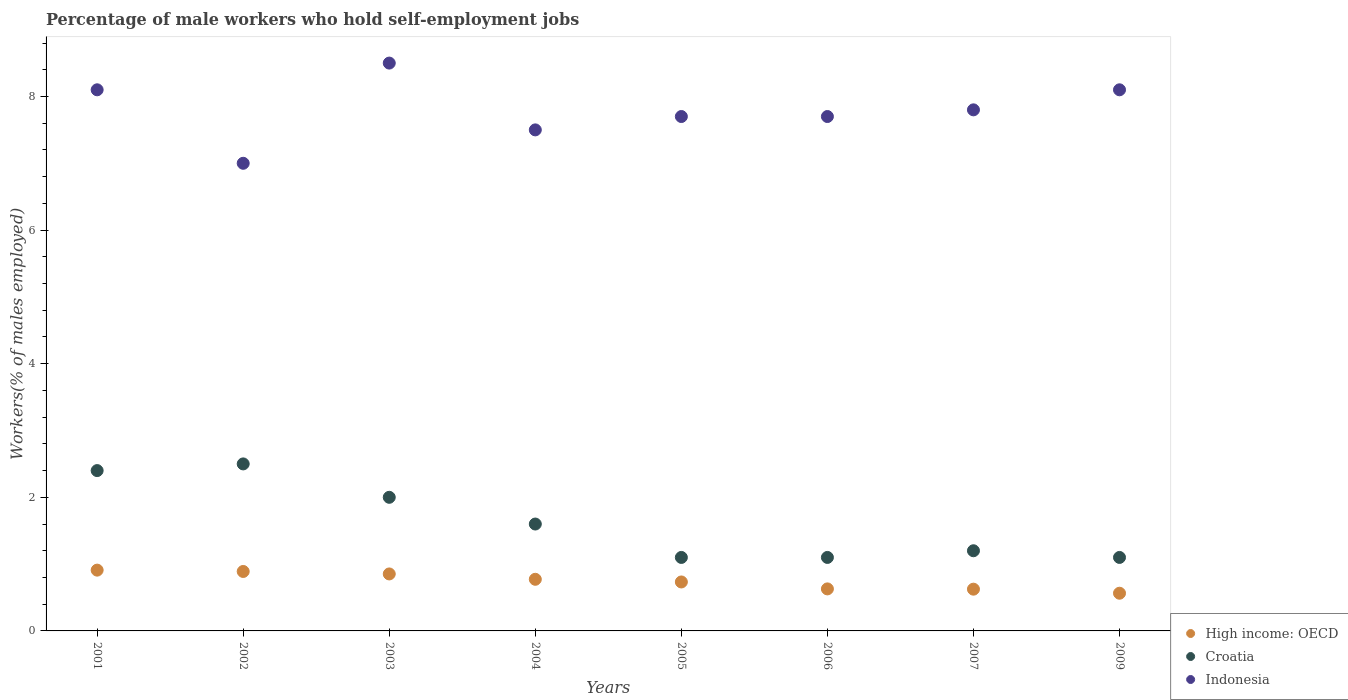How many different coloured dotlines are there?
Make the answer very short. 3. What is the percentage of self-employed male workers in Croatia in 2009?
Give a very brief answer. 1.1. Across all years, what is the minimum percentage of self-employed male workers in High income: OECD?
Make the answer very short. 0.56. What is the total percentage of self-employed male workers in Croatia in the graph?
Offer a terse response. 13. What is the difference between the percentage of self-employed male workers in Indonesia in 2006 and that in 2007?
Give a very brief answer. -0.1. What is the difference between the percentage of self-employed male workers in High income: OECD in 2004 and the percentage of self-employed male workers in Croatia in 2007?
Provide a short and direct response. -0.43. What is the average percentage of self-employed male workers in High income: OECD per year?
Your response must be concise. 0.75. In the year 2006, what is the difference between the percentage of self-employed male workers in Croatia and percentage of self-employed male workers in High income: OECD?
Make the answer very short. 0.47. What is the ratio of the percentage of self-employed male workers in Croatia in 2001 to that in 2009?
Your response must be concise. 2.18. Is the difference between the percentage of self-employed male workers in Croatia in 2005 and 2007 greater than the difference between the percentage of self-employed male workers in High income: OECD in 2005 and 2007?
Ensure brevity in your answer.  No. What is the difference between the highest and the second highest percentage of self-employed male workers in Indonesia?
Provide a short and direct response. 0.4. What is the difference between the highest and the lowest percentage of self-employed male workers in High income: OECD?
Provide a succinct answer. 0.35. In how many years, is the percentage of self-employed male workers in Indonesia greater than the average percentage of self-employed male workers in Indonesia taken over all years?
Keep it short and to the point. 4. Is the sum of the percentage of self-employed male workers in Indonesia in 2004 and 2007 greater than the maximum percentage of self-employed male workers in High income: OECD across all years?
Make the answer very short. Yes. Is it the case that in every year, the sum of the percentage of self-employed male workers in Indonesia and percentage of self-employed male workers in Croatia  is greater than the percentage of self-employed male workers in High income: OECD?
Your answer should be very brief. Yes. Does the percentage of self-employed male workers in Indonesia monotonically increase over the years?
Ensure brevity in your answer.  No. Is the percentage of self-employed male workers in Indonesia strictly greater than the percentage of self-employed male workers in High income: OECD over the years?
Keep it short and to the point. Yes. Is the percentage of self-employed male workers in High income: OECD strictly less than the percentage of self-employed male workers in Croatia over the years?
Provide a short and direct response. Yes. How many years are there in the graph?
Your answer should be very brief. 8. Are the values on the major ticks of Y-axis written in scientific E-notation?
Your response must be concise. No. Does the graph contain any zero values?
Offer a very short reply. No. Does the graph contain grids?
Ensure brevity in your answer.  No. What is the title of the graph?
Provide a succinct answer. Percentage of male workers who hold self-employment jobs. What is the label or title of the X-axis?
Provide a short and direct response. Years. What is the label or title of the Y-axis?
Offer a very short reply. Workers(% of males employed). What is the Workers(% of males employed) in High income: OECD in 2001?
Your answer should be very brief. 0.91. What is the Workers(% of males employed) in Croatia in 2001?
Your answer should be very brief. 2.4. What is the Workers(% of males employed) of Indonesia in 2001?
Provide a short and direct response. 8.1. What is the Workers(% of males employed) of High income: OECD in 2002?
Give a very brief answer. 0.89. What is the Workers(% of males employed) in High income: OECD in 2003?
Provide a short and direct response. 0.85. What is the Workers(% of males employed) in High income: OECD in 2004?
Your answer should be compact. 0.77. What is the Workers(% of males employed) in Croatia in 2004?
Provide a succinct answer. 1.6. What is the Workers(% of males employed) of High income: OECD in 2005?
Provide a succinct answer. 0.73. What is the Workers(% of males employed) of Croatia in 2005?
Give a very brief answer. 1.1. What is the Workers(% of males employed) of Indonesia in 2005?
Your answer should be very brief. 7.7. What is the Workers(% of males employed) of High income: OECD in 2006?
Your answer should be compact. 0.63. What is the Workers(% of males employed) of Croatia in 2006?
Give a very brief answer. 1.1. What is the Workers(% of males employed) in Indonesia in 2006?
Your answer should be compact. 7.7. What is the Workers(% of males employed) in High income: OECD in 2007?
Provide a succinct answer. 0.62. What is the Workers(% of males employed) of Croatia in 2007?
Offer a very short reply. 1.2. What is the Workers(% of males employed) in Indonesia in 2007?
Your response must be concise. 7.8. What is the Workers(% of males employed) of High income: OECD in 2009?
Your response must be concise. 0.56. What is the Workers(% of males employed) of Croatia in 2009?
Provide a short and direct response. 1.1. What is the Workers(% of males employed) in Indonesia in 2009?
Your answer should be compact. 8.1. Across all years, what is the maximum Workers(% of males employed) of High income: OECD?
Offer a very short reply. 0.91. Across all years, what is the maximum Workers(% of males employed) of Croatia?
Your response must be concise. 2.5. Across all years, what is the minimum Workers(% of males employed) of High income: OECD?
Ensure brevity in your answer.  0.56. Across all years, what is the minimum Workers(% of males employed) of Croatia?
Ensure brevity in your answer.  1.1. Across all years, what is the minimum Workers(% of males employed) in Indonesia?
Offer a terse response. 7. What is the total Workers(% of males employed) in High income: OECD in the graph?
Ensure brevity in your answer.  5.98. What is the total Workers(% of males employed) of Indonesia in the graph?
Keep it short and to the point. 62.4. What is the difference between the Workers(% of males employed) in High income: OECD in 2001 and that in 2003?
Your response must be concise. 0.06. What is the difference between the Workers(% of males employed) in Indonesia in 2001 and that in 2003?
Offer a terse response. -0.4. What is the difference between the Workers(% of males employed) in High income: OECD in 2001 and that in 2004?
Make the answer very short. 0.14. What is the difference between the Workers(% of males employed) in Indonesia in 2001 and that in 2004?
Your answer should be very brief. 0.6. What is the difference between the Workers(% of males employed) of High income: OECD in 2001 and that in 2005?
Your answer should be compact. 0.18. What is the difference between the Workers(% of males employed) of Croatia in 2001 and that in 2005?
Offer a terse response. 1.3. What is the difference between the Workers(% of males employed) of Indonesia in 2001 and that in 2005?
Offer a very short reply. 0.4. What is the difference between the Workers(% of males employed) of High income: OECD in 2001 and that in 2006?
Provide a succinct answer. 0.28. What is the difference between the Workers(% of males employed) of High income: OECD in 2001 and that in 2007?
Your answer should be very brief. 0.28. What is the difference between the Workers(% of males employed) in Croatia in 2001 and that in 2007?
Your answer should be compact. 1.2. What is the difference between the Workers(% of males employed) of Indonesia in 2001 and that in 2007?
Your answer should be compact. 0.3. What is the difference between the Workers(% of males employed) of High income: OECD in 2001 and that in 2009?
Ensure brevity in your answer.  0.35. What is the difference between the Workers(% of males employed) in Croatia in 2001 and that in 2009?
Ensure brevity in your answer.  1.3. What is the difference between the Workers(% of males employed) of Indonesia in 2001 and that in 2009?
Offer a terse response. 0. What is the difference between the Workers(% of males employed) in High income: OECD in 2002 and that in 2003?
Offer a terse response. 0.04. What is the difference between the Workers(% of males employed) of Croatia in 2002 and that in 2003?
Make the answer very short. 0.5. What is the difference between the Workers(% of males employed) in High income: OECD in 2002 and that in 2004?
Provide a succinct answer. 0.12. What is the difference between the Workers(% of males employed) in High income: OECD in 2002 and that in 2005?
Offer a very short reply. 0.16. What is the difference between the Workers(% of males employed) of High income: OECD in 2002 and that in 2006?
Your answer should be compact. 0.26. What is the difference between the Workers(% of males employed) of Croatia in 2002 and that in 2006?
Your response must be concise. 1.4. What is the difference between the Workers(% of males employed) of Indonesia in 2002 and that in 2006?
Your response must be concise. -0.7. What is the difference between the Workers(% of males employed) of High income: OECD in 2002 and that in 2007?
Give a very brief answer. 0.27. What is the difference between the Workers(% of males employed) in Croatia in 2002 and that in 2007?
Provide a succinct answer. 1.3. What is the difference between the Workers(% of males employed) in High income: OECD in 2002 and that in 2009?
Keep it short and to the point. 0.33. What is the difference between the Workers(% of males employed) of Croatia in 2002 and that in 2009?
Your answer should be very brief. 1.4. What is the difference between the Workers(% of males employed) in High income: OECD in 2003 and that in 2004?
Make the answer very short. 0.08. What is the difference between the Workers(% of males employed) in Croatia in 2003 and that in 2004?
Ensure brevity in your answer.  0.4. What is the difference between the Workers(% of males employed) of High income: OECD in 2003 and that in 2005?
Your answer should be very brief. 0.12. What is the difference between the Workers(% of males employed) in Indonesia in 2003 and that in 2005?
Your response must be concise. 0.8. What is the difference between the Workers(% of males employed) of High income: OECD in 2003 and that in 2006?
Keep it short and to the point. 0.22. What is the difference between the Workers(% of males employed) of Croatia in 2003 and that in 2006?
Your answer should be compact. 0.9. What is the difference between the Workers(% of males employed) of Indonesia in 2003 and that in 2006?
Provide a short and direct response. 0.8. What is the difference between the Workers(% of males employed) of High income: OECD in 2003 and that in 2007?
Ensure brevity in your answer.  0.23. What is the difference between the Workers(% of males employed) in High income: OECD in 2003 and that in 2009?
Ensure brevity in your answer.  0.29. What is the difference between the Workers(% of males employed) in High income: OECD in 2004 and that in 2005?
Give a very brief answer. 0.04. What is the difference between the Workers(% of males employed) in Croatia in 2004 and that in 2005?
Make the answer very short. 0.5. What is the difference between the Workers(% of males employed) in High income: OECD in 2004 and that in 2006?
Offer a terse response. 0.14. What is the difference between the Workers(% of males employed) of High income: OECD in 2004 and that in 2007?
Keep it short and to the point. 0.15. What is the difference between the Workers(% of males employed) in High income: OECD in 2004 and that in 2009?
Give a very brief answer. 0.21. What is the difference between the Workers(% of males employed) of High income: OECD in 2005 and that in 2006?
Your response must be concise. 0.1. What is the difference between the Workers(% of males employed) in High income: OECD in 2005 and that in 2007?
Your answer should be very brief. 0.11. What is the difference between the Workers(% of males employed) of Indonesia in 2005 and that in 2007?
Give a very brief answer. -0.1. What is the difference between the Workers(% of males employed) of High income: OECD in 2005 and that in 2009?
Keep it short and to the point. 0.17. What is the difference between the Workers(% of males employed) of Croatia in 2005 and that in 2009?
Provide a succinct answer. 0. What is the difference between the Workers(% of males employed) of Indonesia in 2005 and that in 2009?
Keep it short and to the point. -0.4. What is the difference between the Workers(% of males employed) of High income: OECD in 2006 and that in 2007?
Your response must be concise. 0. What is the difference between the Workers(% of males employed) in Croatia in 2006 and that in 2007?
Keep it short and to the point. -0.1. What is the difference between the Workers(% of males employed) in Indonesia in 2006 and that in 2007?
Offer a terse response. -0.1. What is the difference between the Workers(% of males employed) of High income: OECD in 2006 and that in 2009?
Provide a short and direct response. 0.06. What is the difference between the Workers(% of males employed) of Croatia in 2006 and that in 2009?
Keep it short and to the point. 0. What is the difference between the Workers(% of males employed) of Indonesia in 2006 and that in 2009?
Your answer should be very brief. -0.4. What is the difference between the Workers(% of males employed) in High income: OECD in 2007 and that in 2009?
Provide a succinct answer. 0.06. What is the difference between the Workers(% of males employed) in High income: OECD in 2001 and the Workers(% of males employed) in Croatia in 2002?
Your response must be concise. -1.59. What is the difference between the Workers(% of males employed) of High income: OECD in 2001 and the Workers(% of males employed) of Indonesia in 2002?
Offer a terse response. -6.09. What is the difference between the Workers(% of males employed) in Croatia in 2001 and the Workers(% of males employed) in Indonesia in 2002?
Your answer should be compact. -4.6. What is the difference between the Workers(% of males employed) in High income: OECD in 2001 and the Workers(% of males employed) in Croatia in 2003?
Offer a very short reply. -1.09. What is the difference between the Workers(% of males employed) in High income: OECD in 2001 and the Workers(% of males employed) in Indonesia in 2003?
Your response must be concise. -7.59. What is the difference between the Workers(% of males employed) of Croatia in 2001 and the Workers(% of males employed) of Indonesia in 2003?
Make the answer very short. -6.1. What is the difference between the Workers(% of males employed) in High income: OECD in 2001 and the Workers(% of males employed) in Croatia in 2004?
Keep it short and to the point. -0.69. What is the difference between the Workers(% of males employed) of High income: OECD in 2001 and the Workers(% of males employed) of Indonesia in 2004?
Keep it short and to the point. -6.59. What is the difference between the Workers(% of males employed) in High income: OECD in 2001 and the Workers(% of males employed) in Croatia in 2005?
Give a very brief answer. -0.19. What is the difference between the Workers(% of males employed) in High income: OECD in 2001 and the Workers(% of males employed) in Indonesia in 2005?
Provide a succinct answer. -6.79. What is the difference between the Workers(% of males employed) in Croatia in 2001 and the Workers(% of males employed) in Indonesia in 2005?
Offer a terse response. -5.3. What is the difference between the Workers(% of males employed) of High income: OECD in 2001 and the Workers(% of males employed) of Croatia in 2006?
Offer a very short reply. -0.19. What is the difference between the Workers(% of males employed) in High income: OECD in 2001 and the Workers(% of males employed) in Indonesia in 2006?
Your response must be concise. -6.79. What is the difference between the Workers(% of males employed) in High income: OECD in 2001 and the Workers(% of males employed) in Croatia in 2007?
Your answer should be very brief. -0.29. What is the difference between the Workers(% of males employed) in High income: OECD in 2001 and the Workers(% of males employed) in Indonesia in 2007?
Give a very brief answer. -6.89. What is the difference between the Workers(% of males employed) in Croatia in 2001 and the Workers(% of males employed) in Indonesia in 2007?
Keep it short and to the point. -5.4. What is the difference between the Workers(% of males employed) of High income: OECD in 2001 and the Workers(% of males employed) of Croatia in 2009?
Keep it short and to the point. -0.19. What is the difference between the Workers(% of males employed) of High income: OECD in 2001 and the Workers(% of males employed) of Indonesia in 2009?
Offer a terse response. -7.19. What is the difference between the Workers(% of males employed) in Croatia in 2001 and the Workers(% of males employed) in Indonesia in 2009?
Provide a succinct answer. -5.7. What is the difference between the Workers(% of males employed) in High income: OECD in 2002 and the Workers(% of males employed) in Croatia in 2003?
Your answer should be compact. -1.11. What is the difference between the Workers(% of males employed) of High income: OECD in 2002 and the Workers(% of males employed) of Indonesia in 2003?
Provide a short and direct response. -7.61. What is the difference between the Workers(% of males employed) in High income: OECD in 2002 and the Workers(% of males employed) in Croatia in 2004?
Give a very brief answer. -0.71. What is the difference between the Workers(% of males employed) in High income: OECD in 2002 and the Workers(% of males employed) in Indonesia in 2004?
Offer a very short reply. -6.61. What is the difference between the Workers(% of males employed) of Croatia in 2002 and the Workers(% of males employed) of Indonesia in 2004?
Your response must be concise. -5. What is the difference between the Workers(% of males employed) in High income: OECD in 2002 and the Workers(% of males employed) in Croatia in 2005?
Give a very brief answer. -0.21. What is the difference between the Workers(% of males employed) in High income: OECD in 2002 and the Workers(% of males employed) in Indonesia in 2005?
Your answer should be very brief. -6.81. What is the difference between the Workers(% of males employed) of Croatia in 2002 and the Workers(% of males employed) of Indonesia in 2005?
Offer a terse response. -5.2. What is the difference between the Workers(% of males employed) of High income: OECD in 2002 and the Workers(% of males employed) of Croatia in 2006?
Offer a very short reply. -0.21. What is the difference between the Workers(% of males employed) of High income: OECD in 2002 and the Workers(% of males employed) of Indonesia in 2006?
Offer a terse response. -6.81. What is the difference between the Workers(% of males employed) in High income: OECD in 2002 and the Workers(% of males employed) in Croatia in 2007?
Offer a very short reply. -0.31. What is the difference between the Workers(% of males employed) of High income: OECD in 2002 and the Workers(% of males employed) of Indonesia in 2007?
Provide a succinct answer. -6.91. What is the difference between the Workers(% of males employed) in High income: OECD in 2002 and the Workers(% of males employed) in Croatia in 2009?
Offer a very short reply. -0.21. What is the difference between the Workers(% of males employed) in High income: OECD in 2002 and the Workers(% of males employed) in Indonesia in 2009?
Provide a succinct answer. -7.21. What is the difference between the Workers(% of males employed) of Croatia in 2002 and the Workers(% of males employed) of Indonesia in 2009?
Offer a very short reply. -5.6. What is the difference between the Workers(% of males employed) of High income: OECD in 2003 and the Workers(% of males employed) of Croatia in 2004?
Your response must be concise. -0.75. What is the difference between the Workers(% of males employed) of High income: OECD in 2003 and the Workers(% of males employed) of Indonesia in 2004?
Offer a very short reply. -6.65. What is the difference between the Workers(% of males employed) in Croatia in 2003 and the Workers(% of males employed) in Indonesia in 2004?
Keep it short and to the point. -5.5. What is the difference between the Workers(% of males employed) of High income: OECD in 2003 and the Workers(% of males employed) of Croatia in 2005?
Provide a succinct answer. -0.25. What is the difference between the Workers(% of males employed) of High income: OECD in 2003 and the Workers(% of males employed) of Indonesia in 2005?
Provide a short and direct response. -6.85. What is the difference between the Workers(% of males employed) in High income: OECD in 2003 and the Workers(% of males employed) in Croatia in 2006?
Offer a very short reply. -0.25. What is the difference between the Workers(% of males employed) of High income: OECD in 2003 and the Workers(% of males employed) of Indonesia in 2006?
Ensure brevity in your answer.  -6.85. What is the difference between the Workers(% of males employed) in High income: OECD in 2003 and the Workers(% of males employed) in Croatia in 2007?
Give a very brief answer. -0.35. What is the difference between the Workers(% of males employed) in High income: OECD in 2003 and the Workers(% of males employed) in Indonesia in 2007?
Offer a terse response. -6.95. What is the difference between the Workers(% of males employed) of Croatia in 2003 and the Workers(% of males employed) of Indonesia in 2007?
Give a very brief answer. -5.8. What is the difference between the Workers(% of males employed) in High income: OECD in 2003 and the Workers(% of males employed) in Croatia in 2009?
Your answer should be very brief. -0.25. What is the difference between the Workers(% of males employed) of High income: OECD in 2003 and the Workers(% of males employed) of Indonesia in 2009?
Ensure brevity in your answer.  -7.25. What is the difference between the Workers(% of males employed) in High income: OECD in 2004 and the Workers(% of males employed) in Croatia in 2005?
Your response must be concise. -0.33. What is the difference between the Workers(% of males employed) in High income: OECD in 2004 and the Workers(% of males employed) in Indonesia in 2005?
Your answer should be very brief. -6.93. What is the difference between the Workers(% of males employed) of Croatia in 2004 and the Workers(% of males employed) of Indonesia in 2005?
Offer a terse response. -6.1. What is the difference between the Workers(% of males employed) in High income: OECD in 2004 and the Workers(% of males employed) in Croatia in 2006?
Provide a succinct answer. -0.33. What is the difference between the Workers(% of males employed) of High income: OECD in 2004 and the Workers(% of males employed) of Indonesia in 2006?
Provide a succinct answer. -6.93. What is the difference between the Workers(% of males employed) of High income: OECD in 2004 and the Workers(% of males employed) of Croatia in 2007?
Offer a very short reply. -0.43. What is the difference between the Workers(% of males employed) in High income: OECD in 2004 and the Workers(% of males employed) in Indonesia in 2007?
Ensure brevity in your answer.  -7.03. What is the difference between the Workers(% of males employed) in High income: OECD in 2004 and the Workers(% of males employed) in Croatia in 2009?
Offer a very short reply. -0.33. What is the difference between the Workers(% of males employed) in High income: OECD in 2004 and the Workers(% of males employed) in Indonesia in 2009?
Ensure brevity in your answer.  -7.33. What is the difference between the Workers(% of males employed) in Croatia in 2004 and the Workers(% of males employed) in Indonesia in 2009?
Give a very brief answer. -6.5. What is the difference between the Workers(% of males employed) of High income: OECD in 2005 and the Workers(% of males employed) of Croatia in 2006?
Ensure brevity in your answer.  -0.37. What is the difference between the Workers(% of males employed) of High income: OECD in 2005 and the Workers(% of males employed) of Indonesia in 2006?
Offer a terse response. -6.97. What is the difference between the Workers(% of males employed) of Croatia in 2005 and the Workers(% of males employed) of Indonesia in 2006?
Provide a short and direct response. -6.6. What is the difference between the Workers(% of males employed) of High income: OECD in 2005 and the Workers(% of males employed) of Croatia in 2007?
Provide a short and direct response. -0.47. What is the difference between the Workers(% of males employed) of High income: OECD in 2005 and the Workers(% of males employed) of Indonesia in 2007?
Your answer should be very brief. -7.07. What is the difference between the Workers(% of males employed) of High income: OECD in 2005 and the Workers(% of males employed) of Croatia in 2009?
Give a very brief answer. -0.37. What is the difference between the Workers(% of males employed) of High income: OECD in 2005 and the Workers(% of males employed) of Indonesia in 2009?
Ensure brevity in your answer.  -7.37. What is the difference between the Workers(% of males employed) in High income: OECD in 2006 and the Workers(% of males employed) in Croatia in 2007?
Provide a succinct answer. -0.57. What is the difference between the Workers(% of males employed) of High income: OECD in 2006 and the Workers(% of males employed) of Indonesia in 2007?
Keep it short and to the point. -7.17. What is the difference between the Workers(% of males employed) in Croatia in 2006 and the Workers(% of males employed) in Indonesia in 2007?
Your answer should be compact. -6.7. What is the difference between the Workers(% of males employed) of High income: OECD in 2006 and the Workers(% of males employed) of Croatia in 2009?
Ensure brevity in your answer.  -0.47. What is the difference between the Workers(% of males employed) in High income: OECD in 2006 and the Workers(% of males employed) in Indonesia in 2009?
Keep it short and to the point. -7.47. What is the difference between the Workers(% of males employed) in High income: OECD in 2007 and the Workers(% of males employed) in Croatia in 2009?
Keep it short and to the point. -0.47. What is the difference between the Workers(% of males employed) in High income: OECD in 2007 and the Workers(% of males employed) in Indonesia in 2009?
Provide a succinct answer. -7.47. What is the average Workers(% of males employed) in High income: OECD per year?
Offer a very short reply. 0.75. What is the average Workers(% of males employed) of Croatia per year?
Ensure brevity in your answer.  1.62. What is the average Workers(% of males employed) in Indonesia per year?
Ensure brevity in your answer.  7.8. In the year 2001, what is the difference between the Workers(% of males employed) of High income: OECD and Workers(% of males employed) of Croatia?
Ensure brevity in your answer.  -1.49. In the year 2001, what is the difference between the Workers(% of males employed) of High income: OECD and Workers(% of males employed) of Indonesia?
Give a very brief answer. -7.19. In the year 2002, what is the difference between the Workers(% of males employed) in High income: OECD and Workers(% of males employed) in Croatia?
Ensure brevity in your answer.  -1.61. In the year 2002, what is the difference between the Workers(% of males employed) of High income: OECD and Workers(% of males employed) of Indonesia?
Ensure brevity in your answer.  -6.11. In the year 2003, what is the difference between the Workers(% of males employed) of High income: OECD and Workers(% of males employed) of Croatia?
Provide a short and direct response. -1.15. In the year 2003, what is the difference between the Workers(% of males employed) in High income: OECD and Workers(% of males employed) in Indonesia?
Ensure brevity in your answer.  -7.65. In the year 2004, what is the difference between the Workers(% of males employed) in High income: OECD and Workers(% of males employed) in Croatia?
Your answer should be very brief. -0.83. In the year 2004, what is the difference between the Workers(% of males employed) in High income: OECD and Workers(% of males employed) in Indonesia?
Offer a terse response. -6.73. In the year 2005, what is the difference between the Workers(% of males employed) in High income: OECD and Workers(% of males employed) in Croatia?
Provide a short and direct response. -0.37. In the year 2005, what is the difference between the Workers(% of males employed) in High income: OECD and Workers(% of males employed) in Indonesia?
Offer a very short reply. -6.97. In the year 2005, what is the difference between the Workers(% of males employed) in Croatia and Workers(% of males employed) in Indonesia?
Provide a short and direct response. -6.6. In the year 2006, what is the difference between the Workers(% of males employed) of High income: OECD and Workers(% of males employed) of Croatia?
Your answer should be compact. -0.47. In the year 2006, what is the difference between the Workers(% of males employed) in High income: OECD and Workers(% of males employed) in Indonesia?
Your answer should be very brief. -7.07. In the year 2007, what is the difference between the Workers(% of males employed) in High income: OECD and Workers(% of males employed) in Croatia?
Provide a short and direct response. -0.57. In the year 2007, what is the difference between the Workers(% of males employed) in High income: OECD and Workers(% of males employed) in Indonesia?
Offer a very short reply. -7.17. In the year 2007, what is the difference between the Workers(% of males employed) in Croatia and Workers(% of males employed) in Indonesia?
Give a very brief answer. -6.6. In the year 2009, what is the difference between the Workers(% of males employed) in High income: OECD and Workers(% of males employed) in Croatia?
Keep it short and to the point. -0.54. In the year 2009, what is the difference between the Workers(% of males employed) of High income: OECD and Workers(% of males employed) of Indonesia?
Give a very brief answer. -7.54. What is the ratio of the Workers(% of males employed) of High income: OECD in 2001 to that in 2002?
Provide a succinct answer. 1.02. What is the ratio of the Workers(% of males employed) of Indonesia in 2001 to that in 2002?
Make the answer very short. 1.16. What is the ratio of the Workers(% of males employed) of High income: OECD in 2001 to that in 2003?
Your answer should be compact. 1.07. What is the ratio of the Workers(% of males employed) of Indonesia in 2001 to that in 2003?
Your response must be concise. 0.95. What is the ratio of the Workers(% of males employed) of High income: OECD in 2001 to that in 2004?
Provide a succinct answer. 1.18. What is the ratio of the Workers(% of males employed) in Indonesia in 2001 to that in 2004?
Give a very brief answer. 1.08. What is the ratio of the Workers(% of males employed) in High income: OECD in 2001 to that in 2005?
Your response must be concise. 1.24. What is the ratio of the Workers(% of males employed) of Croatia in 2001 to that in 2005?
Ensure brevity in your answer.  2.18. What is the ratio of the Workers(% of males employed) in Indonesia in 2001 to that in 2005?
Your response must be concise. 1.05. What is the ratio of the Workers(% of males employed) of High income: OECD in 2001 to that in 2006?
Make the answer very short. 1.45. What is the ratio of the Workers(% of males employed) in Croatia in 2001 to that in 2006?
Your answer should be compact. 2.18. What is the ratio of the Workers(% of males employed) in Indonesia in 2001 to that in 2006?
Give a very brief answer. 1.05. What is the ratio of the Workers(% of males employed) of High income: OECD in 2001 to that in 2007?
Make the answer very short. 1.46. What is the ratio of the Workers(% of males employed) in Indonesia in 2001 to that in 2007?
Ensure brevity in your answer.  1.04. What is the ratio of the Workers(% of males employed) in High income: OECD in 2001 to that in 2009?
Your response must be concise. 1.61. What is the ratio of the Workers(% of males employed) of Croatia in 2001 to that in 2009?
Keep it short and to the point. 2.18. What is the ratio of the Workers(% of males employed) in Indonesia in 2001 to that in 2009?
Offer a very short reply. 1. What is the ratio of the Workers(% of males employed) in High income: OECD in 2002 to that in 2003?
Give a very brief answer. 1.04. What is the ratio of the Workers(% of males employed) of Croatia in 2002 to that in 2003?
Provide a succinct answer. 1.25. What is the ratio of the Workers(% of males employed) of Indonesia in 2002 to that in 2003?
Make the answer very short. 0.82. What is the ratio of the Workers(% of males employed) of High income: OECD in 2002 to that in 2004?
Your answer should be very brief. 1.15. What is the ratio of the Workers(% of males employed) in Croatia in 2002 to that in 2004?
Keep it short and to the point. 1.56. What is the ratio of the Workers(% of males employed) in Indonesia in 2002 to that in 2004?
Your response must be concise. 0.93. What is the ratio of the Workers(% of males employed) in High income: OECD in 2002 to that in 2005?
Your response must be concise. 1.21. What is the ratio of the Workers(% of males employed) of Croatia in 2002 to that in 2005?
Give a very brief answer. 2.27. What is the ratio of the Workers(% of males employed) in High income: OECD in 2002 to that in 2006?
Keep it short and to the point. 1.41. What is the ratio of the Workers(% of males employed) of Croatia in 2002 to that in 2006?
Ensure brevity in your answer.  2.27. What is the ratio of the Workers(% of males employed) of High income: OECD in 2002 to that in 2007?
Keep it short and to the point. 1.42. What is the ratio of the Workers(% of males employed) in Croatia in 2002 to that in 2007?
Make the answer very short. 2.08. What is the ratio of the Workers(% of males employed) of Indonesia in 2002 to that in 2007?
Provide a short and direct response. 0.9. What is the ratio of the Workers(% of males employed) of High income: OECD in 2002 to that in 2009?
Keep it short and to the point. 1.58. What is the ratio of the Workers(% of males employed) in Croatia in 2002 to that in 2009?
Provide a succinct answer. 2.27. What is the ratio of the Workers(% of males employed) in Indonesia in 2002 to that in 2009?
Your response must be concise. 0.86. What is the ratio of the Workers(% of males employed) in High income: OECD in 2003 to that in 2004?
Your answer should be compact. 1.1. What is the ratio of the Workers(% of males employed) in Croatia in 2003 to that in 2004?
Keep it short and to the point. 1.25. What is the ratio of the Workers(% of males employed) in Indonesia in 2003 to that in 2004?
Provide a short and direct response. 1.13. What is the ratio of the Workers(% of males employed) of High income: OECD in 2003 to that in 2005?
Your response must be concise. 1.16. What is the ratio of the Workers(% of males employed) in Croatia in 2003 to that in 2005?
Make the answer very short. 1.82. What is the ratio of the Workers(% of males employed) in Indonesia in 2003 to that in 2005?
Make the answer very short. 1.1. What is the ratio of the Workers(% of males employed) of High income: OECD in 2003 to that in 2006?
Give a very brief answer. 1.36. What is the ratio of the Workers(% of males employed) in Croatia in 2003 to that in 2006?
Your answer should be compact. 1.82. What is the ratio of the Workers(% of males employed) of Indonesia in 2003 to that in 2006?
Give a very brief answer. 1.1. What is the ratio of the Workers(% of males employed) in High income: OECD in 2003 to that in 2007?
Offer a terse response. 1.36. What is the ratio of the Workers(% of males employed) in Croatia in 2003 to that in 2007?
Provide a short and direct response. 1.67. What is the ratio of the Workers(% of males employed) of Indonesia in 2003 to that in 2007?
Your answer should be compact. 1.09. What is the ratio of the Workers(% of males employed) of High income: OECD in 2003 to that in 2009?
Provide a short and direct response. 1.51. What is the ratio of the Workers(% of males employed) of Croatia in 2003 to that in 2009?
Give a very brief answer. 1.82. What is the ratio of the Workers(% of males employed) in Indonesia in 2003 to that in 2009?
Ensure brevity in your answer.  1.05. What is the ratio of the Workers(% of males employed) in High income: OECD in 2004 to that in 2005?
Your answer should be very brief. 1.05. What is the ratio of the Workers(% of males employed) of Croatia in 2004 to that in 2005?
Make the answer very short. 1.45. What is the ratio of the Workers(% of males employed) of High income: OECD in 2004 to that in 2006?
Your answer should be compact. 1.23. What is the ratio of the Workers(% of males employed) in Croatia in 2004 to that in 2006?
Offer a terse response. 1.45. What is the ratio of the Workers(% of males employed) of Indonesia in 2004 to that in 2006?
Your answer should be very brief. 0.97. What is the ratio of the Workers(% of males employed) in High income: OECD in 2004 to that in 2007?
Offer a very short reply. 1.24. What is the ratio of the Workers(% of males employed) in Croatia in 2004 to that in 2007?
Offer a terse response. 1.33. What is the ratio of the Workers(% of males employed) in Indonesia in 2004 to that in 2007?
Your answer should be very brief. 0.96. What is the ratio of the Workers(% of males employed) of High income: OECD in 2004 to that in 2009?
Your answer should be very brief. 1.37. What is the ratio of the Workers(% of males employed) of Croatia in 2004 to that in 2009?
Keep it short and to the point. 1.45. What is the ratio of the Workers(% of males employed) in Indonesia in 2004 to that in 2009?
Offer a terse response. 0.93. What is the ratio of the Workers(% of males employed) in High income: OECD in 2005 to that in 2006?
Provide a succinct answer. 1.17. What is the ratio of the Workers(% of males employed) of High income: OECD in 2005 to that in 2007?
Offer a terse response. 1.17. What is the ratio of the Workers(% of males employed) in Indonesia in 2005 to that in 2007?
Keep it short and to the point. 0.99. What is the ratio of the Workers(% of males employed) of High income: OECD in 2005 to that in 2009?
Offer a very short reply. 1.3. What is the ratio of the Workers(% of males employed) of Indonesia in 2005 to that in 2009?
Offer a terse response. 0.95. What is the ratio of the Workers(% of males employed) in High income: OECD in 2006 to that in 2007?
Keep it short and to the point. 1.01. What is the ratio of the Workers(% of males employed) of Indonesia in 2006 to that in 2007?
Offer a very short reply. 0.99. What is the ratio of the Workers(% of males employed) in High income: OECD in 2006 to that in 2009?
Keep it short and to the point. 1.11. What is the ratio of the Workers(% of males employed) in Indonesia in 2006 to that in 2009?
Provide a succinct answer. 0.95. What is the ratio of the Workers(% of males employed) in High income: OECD in 2007 to that in 2009?
Give a very brief answer. 1.11. What is the ratio of the Workers(% of males employed) in Croatia in 2007 to that in 2009?
Your response must be concise. 1.09. What is the ratio of the Workers(% of males employed) in Indonesia in 2007 to that in 2009?
Give a very brief answer. 0.96. What is the difference between the highest and the lowest Workers(% of males employed) of High income: OECD?
Make the answer very short. 0.35. What is the difference between the highest and the lowest Workers(% of males employed) in Croatia?
Provide a succinct answer. 1.4. What is the difference between the highest and the lowest Workers(% of males employed) in Indonesia?
Offer a very short reply. 1.5. 